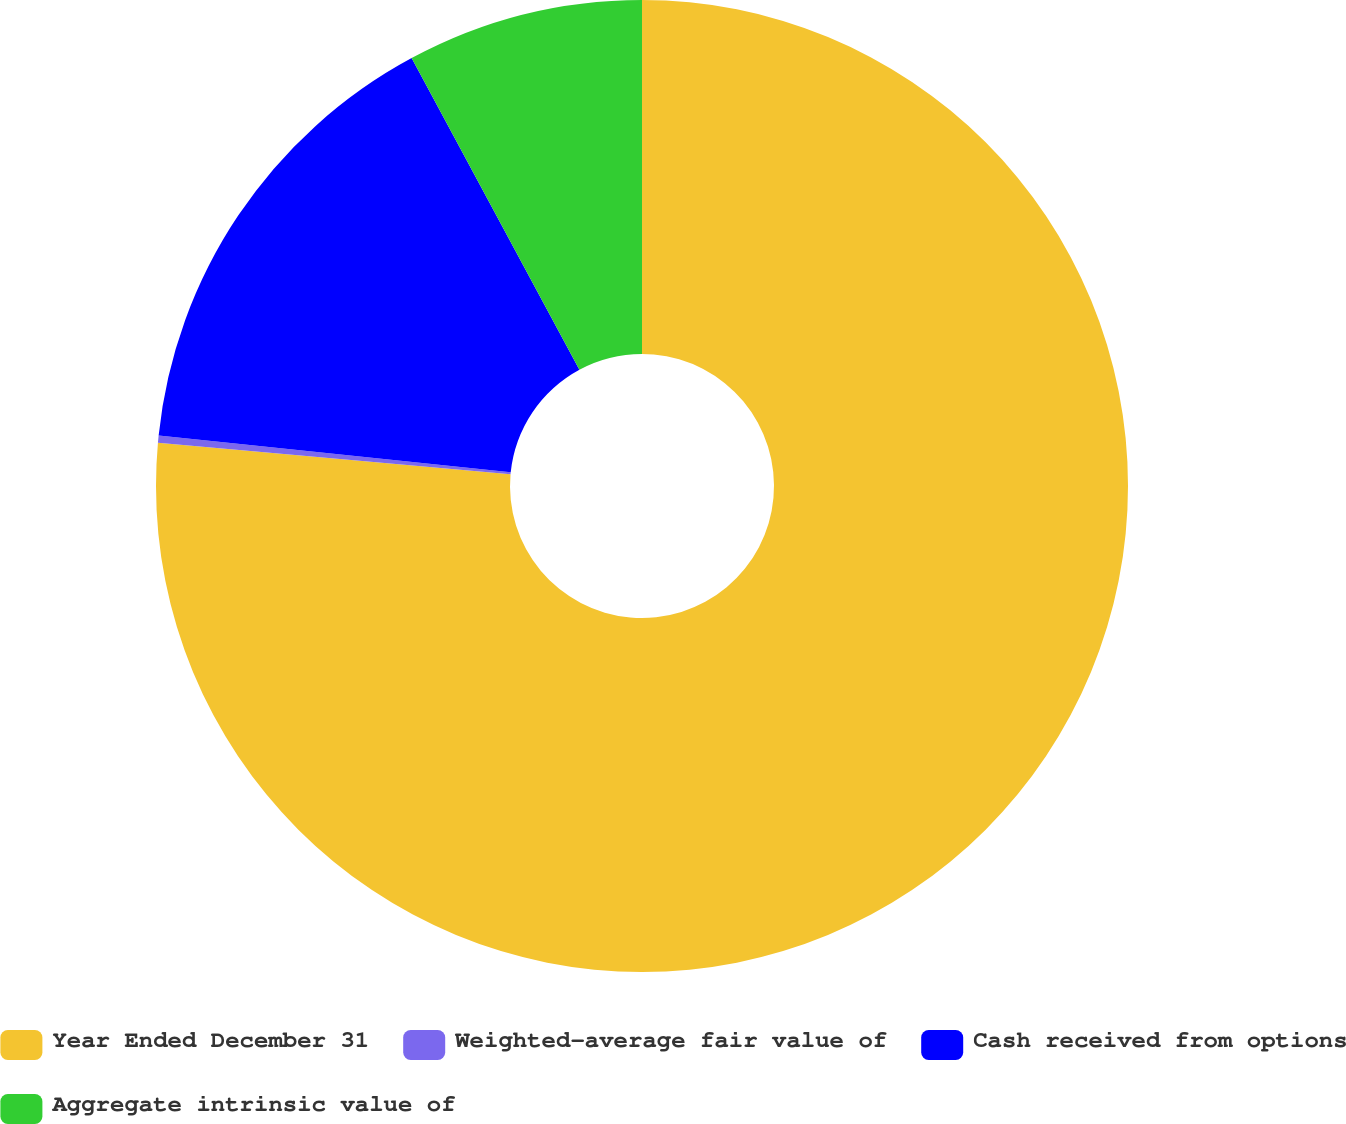<chart> <loc_0><loc_0><loc_500><loc_500><pie_chart><fcel>Year Ended December 31<fcel>Weighted-average fair value of<fcel>Cash received from options<fcel>Aggregate intrinsic value of<nl><fcel>76.42%<fcel>0.24%<fcel>15.48%<fcel>7.86%<nl></chart> 